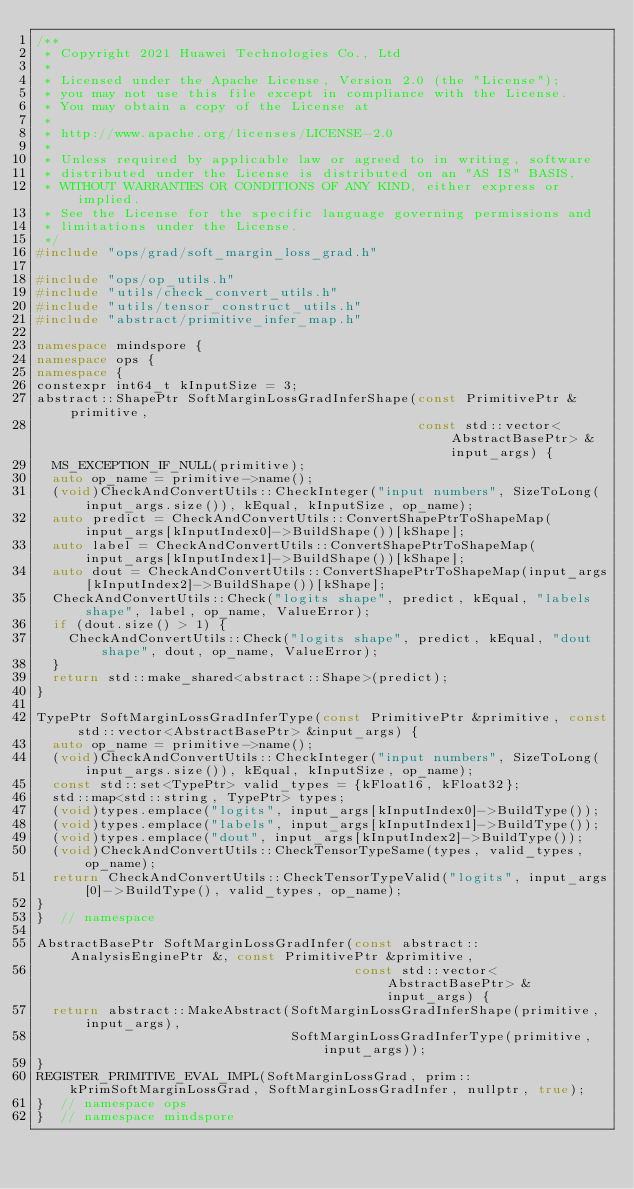Convert code to text. <code><loc_0><loc_0><loc_500><loc_500><_C++_>/**
 * Copyright 2021 Huawei Technologies Co., Ltd
 *
 * Licensed under the Apache License, Version 2.0 (the "License");
 * you may not use this file except in compliance with the License.
 * You may obtain a copy of the License at
 *
 * http://www.apache.org/licenses/LICENSE-2.0
 *
 * Unless required by applicable law or agreed to in writing, software
 * distributed under the License is distributed on an "AS IS" BASIS,
 * WITHOUT WARRANTIES OR CONDITIONS OF ANY KIND, either express or implied.
 * See the License for the specific language governing permissions and
 * limitations under the License.
 */
#include "ops/grad/soft_margin_loss_grad.h"

#include "ops/op_utils.h"
#include "utils/check_convert_utils.h"
#include "utils/tensor_construct_utils.h"
#include "abstract/primitive_infer_map.h"

namespace mindspore {
namespace ops {
namespace {
constexpr int64_t kInputSize = 3;
abstract::ShapePtr SoftMarginLossGradInferShape(const PrimitivePtr &primitive,
                                                const std::vector<AbstractBasePtr> &input_args) {
  MS_EXCEPTION_IF_NULL(primitive);
  auto op_name = primitive->name();
  (void)CheckAndConvertUtils::CheckInteger("input numbers", SizeToLong(input_args.size()), kEqual, kInputSize, op_name);
  auto predict = CheckAndConvertUtils::ConvertShapePtrToShapeMap(input_args[kInputIndex0]->BuildShape())[kShape];
  auto label = CheckAndConvertUtils::ConvertShapePtrToShapeMap(input_args[kInputIndex1]->BuildShape())[kShape];
  auto dout = CheckAndConvertUtils::ConvertShapePtrToShapeMap(input_args[kInputIndex2]->BuildShape())[kShape];
  CheckAndConvertUtils::Check("logits shape", predict, kEqual, "labels shape", label, op_name, ValueError);
  if (dout.size() > 1) {
    CheckAndConvertUtils::Check("logits shape", predict, kEqual, "dout shape", dout, op_name, ValueError);
  }
  return std::make_shared<abstract::Shape>(predict);
}

TypePtr SoftMarginLossGradInferType(const PrimitivePtr &primitive, const std::vector<AbstractBasePtr> &input_args) {
  auto op_name = primitive->name();
  (void)CheckAndConvertUtils::CheckInteger("input numbers", SizeToLong(input_args.size()), kEqual, kInputSize, op_name);
  const std::set<TypePtr> valid_types = {kFloat16, kFloat32};
  std::map<std::string, TypePtr> types;
  (void)types.emplace("logits", input_args[kInputIndex0]->BuildType());
  (void)types.emplace("labels", input_args[kInputIndex1]->BuildType());
  (void)types.emplace("dout", input_args[kInputIndex2]->BuildType());
  (void)CheckAndConvertUtils::CheckTensorTypeSame(types, valid_types, op_name);
  return CheckAndConvertUtils::CheckTensorTypeValid("logits", input_args[0]->BuildType(), valid_types, op_name);
}
}  // namespace

AbstractBasePtr SoftMarginLossGradInfer(const abstract::AnalysisEnginePtr &, const PrimitivePtr &primitive,
                                        const std::vector<AbstractBasePtr> &input_args) {
  return abstract::MakeAbstract(SoftMarginLossGradInferShape(primitive, input_args),
                                SoftMarginLossGradInferType(primitive, input_args));
}
REGISTER_PRIMITIVE_EVAL_IMPL(SoftMarginLossGrad, prim::kPrimSoftMarginLossGrad, SoftMarginLossGradInfer, nullptr, true);
}  // namespace ops
}  // namespace mindspore
</code> 